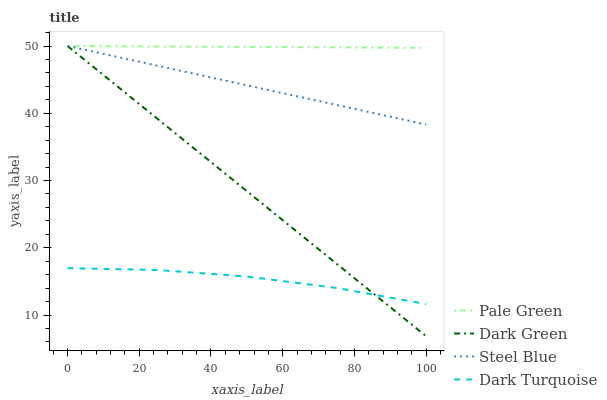Does Dark Turquoise have the minimum area under the curve?
Answer yes or no. Yes. Does Pale Green have the maximum area under the curve?
Answer yes or no. Yes. Does Steel Blue have the minimum area under the curve?
Answer yes or no. No. Does Steel Blue have the maximum area under the curve?
Answer yes or no. No. Is Steel Blue the smoothest?
Answer yes or no. Yes. Is Dark Turquoise the roughest?
Answer yes or no. Yes. Is Pale Green the smoothest?
Answer yes or no. No. Is Pale Green the roughest?
Answer yes or no. No. Does Steel Blue have the lowest value?
Answer yes or no. No. Is Dark Turquoise less than Pale Green?
Answer yes or no. Yes. Is Pale Green greater than Dark Turquoise?
Answer yes or no. Yes. Does Dark Turquoise intersect Pale Green?
Answer yes or no. No. 